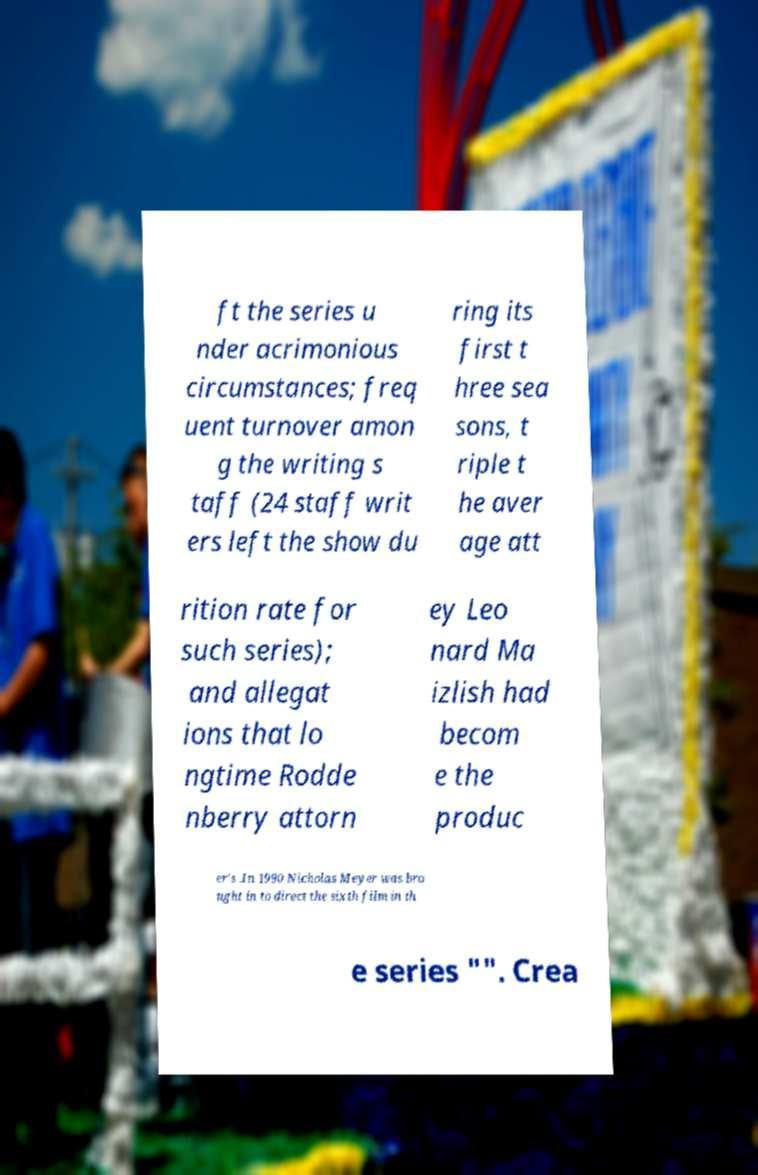What messages or text are displayed in this image? I need them in a readable, typed format. ft the series u nder acrimonious circumstances; freq uent turnover amon g the writing s taff (24 staff writ ers left the show du ring its first t hree sea sons, t riple t he aver age att rition rate for such series); and allegat ions that lo ngtime Rodde nberry attorn ey Leo nard Ma izlish had becom e the produc er's .In 1990 Nicholas Meyer was bro ught in to direct the sixth film in th e series "". Crea 